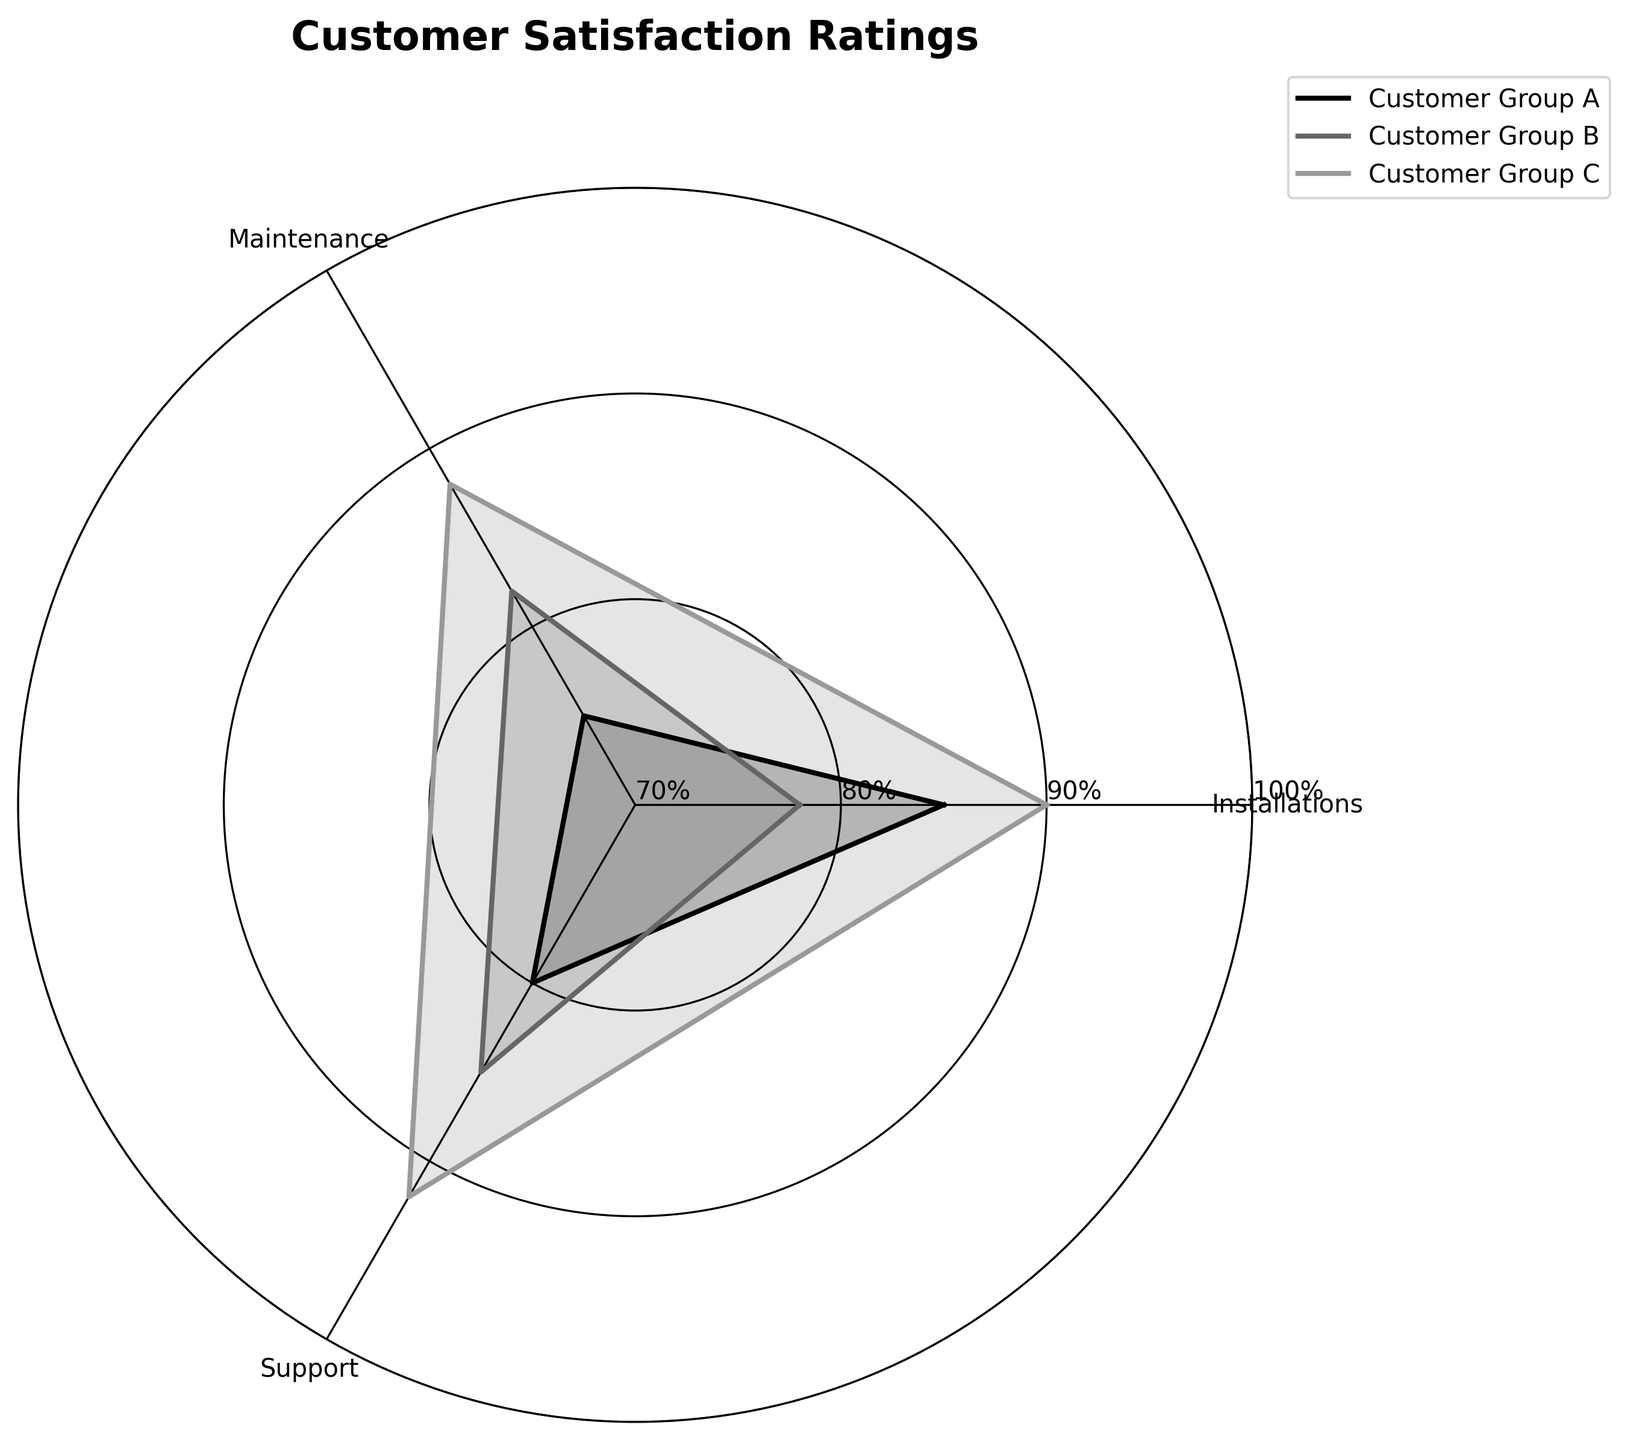What's the highest satisfaction rating for Customer Group A? The highest satisfaction rating for Customer Group A can be found by looking at the highest point in the "Installations," "Maintenance," or "Support" category for that group. In this case, it's in "Installations" with a rating of 85.
Answer: 85 Which category does Customer Group B rate the highest? By examining the radar chart, the highest point for Customer Group B is in the "Support" category with a rating of 85.
Answer: Support What's the average satisfaction rating for Customer Group C? To find the average rating for Customer Group C, add the ratings for "Installations," "Maintenance," and "Support" and then divide by 3. The ratings are 90, 88, and 92. Therefore, (90 + 88 + 92) / 3 = 90.
Answer: 90 Which customer group has the lowest rating in any category? Look at the lowest points on the radar chart for each customer group. Customer Group B has the lowest point at 78 in the "Installations" category.
Answer: Customer Group B How much higher is Customer Group C's rating in Support compared to Maintenance? The ratings for Customer Group C are 92 for Support and 88 for Maintenance. The difference is 92 - 88 = 4.
Answer: 4 Which category shows the most variation in customer ratings? Examine the differences between the highest and lowest ratings for each category across the customer groups. "Support" varies from 80 to 92, which is 12. "Installations" varies from 78 to 90, which is 12. "Maintenance" varies from 75 to 88, which is 13. Maintenance shows the most variation.
Answer: Maintenance Are any customer groups equally satisfied across any two categories? Check if any customer group's ratings are the same in any two categories. None of the groups have the same rating across any two categories.
Answer: No Which customer group has the highest overall average satisfaction rating? Calculate the average satisfaction ratings for all categories for each customer group. Customer Group A: (85 + 75 + 80) / 3 = 80. Customer Group B: (78 + 82 + 85) / 3 ≈ 81.67. Customer Group C: (90 + 88 + 92) / 3 = 90. Customer Group C has the highest overall average.
Answer: Customer Group C How does Customer Group A's satisfaction in Maintenance compare to others? Examine the Maintenance ratings for all groups. Customer Group A rates it at 75, compared to Customer Group B's 82 and Customer Group C's 88. Group A has the lowest rating in this category.
Answer: Customer Group A rates Maintenance the lowest 